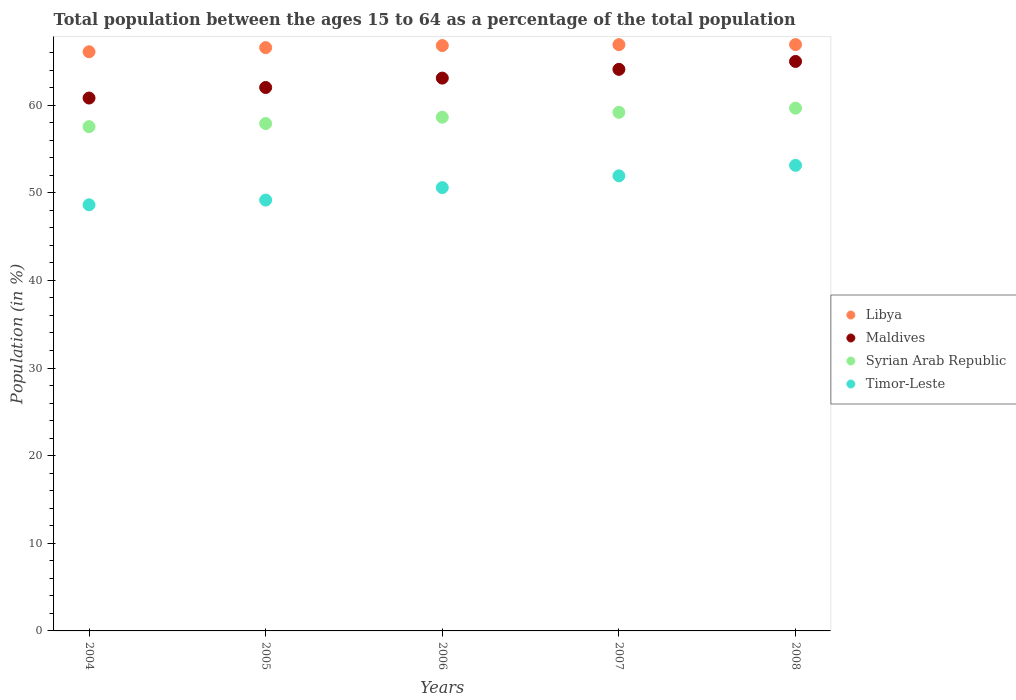How many different coloured dotlines are there?
Provide a succinct answer. 4. Is the number of dotlines equal to the number of legend labels?
Provide a short and direct response. Yes. What is the percentage of the population ages 15 to 64 in Maldives in 2006?
Your response must be concise. 63.08. Across all years, what is the maximum percentage of the population ages 15 to 64 in Syrian Arab Republic?
Ensure brevity in your answer.  59.65. Across all years, what is the minimum percentage of the population ages 15 to 64 in Maldives?
Offer a very short reply. 60.81. What is the total percentage of the population ages 15 to 64 in Timor-Leste in the graph?
Offer a terse response. 253.43. What is the difference between the percentage of the population ages 15 to 64 in Syrian Arab Republic in 2005 and that in 2006?
Make the answer very short. -0.72. What is the difference between the percentage of the population ages 15 to 64 in Maldives in 2006 and the percentage of the population ages 15 to 64 in Libya in 2007?
Keep it short and to the point. -3.82. What is the average percentage of the population ages 15 to 64 in Timor-Leste per year?
Ensure brevity in your answer.  50.69. In the year 2008, what is the difference between the percentage of the population ages 15 to 64 in Libya and percentage of the population ages 15 to 64 in Maldives?
Your answer should be compact. 1.92. In how many years, is the percentage of the population ages 15 to 64 in Timor-Leste greater than 24?
Keep it short and to the point. 5. What is the ratio of the percentage of the population ages 15 to 64 in Libya in 2005 to that in 2007?
Provide a succinct answer. 0.99. Is the percentage of the population ages 15 to 64 in Timor-Leste in 2005 less than that in 2008?
Your answer should be very brief. Yes. Is the difference between the percentage of the population ages 15 to 64 in Libya in 2005 and 2006 greater than the difference between the percentage of the population ages 15 to 64 in Maldives in 2005 and 2006?
Your response must be concise. Yes. What is the difference between the highest and the second highest percentage of the population ages 15 to 64 in Timor-Leste?
Give a very brief answer. 1.2. What is the difference between the highest and the lowest percentage of the population ages 15 to 64 in Syrian Arab Republic?
Offer a very short reply. 2.11. Is it the case that in every year, the sum of the percentage of the population ages 15 to 64 in Maldives and percentage of the population ages 15 to 64 in Timor-Leste  is greater than the sum of percentage of the population ages 15 to 64 in Syrian Arab Republic and percentage of the population ages 15 to 64 in Libya?
Your response must be concise. No. Is it the case that in every year, the sum of the percentage of the population ages 15 to 64 in Syrian Arab Republic and percentage of the population ages 15 to 64 in Maldives  is greater than the percentage of the population ages 15 to 64 in Libya?
Your answer should be very brief. Yes. Is the percentage of the population ages 15 to 64 in Syrian Arab Republic strictly greater than the percentage of the population ages 15 to 64 in Maldives over the years?
Ensure brevity in your answer.  No. Is the percentage of the population ages 15 to 64 in Syrian Arab Republic strictly less than the percentage of the population ages 15 to 64 in Maldives over the years?
Your answer should be very brief. Yes. How many years are there in the graph?
Your answer should be compact. 5. Are the values on the major ticks of Y-axis written in scientific E-notation?
Provide a succinct answer. No. Does the graph contain grids?
Your answer should be compact. No. Where does the legend appear in the graph?
Your answer should be very brief. Center right. What is the title of the graph?
Provide a succinct answer. Total population between the ages 15 to 64 as a percentage of the total population. What is the label or title of the Y-axis?
Make the answer very short. Population (in %). What is the Population (in %) of Libya in 2004?
Your answer should be compact. 66.09. What is the Population (in %) in Maldives in 2004?
Give a very brief answer. 60.81. What is the Population (in %) of Syrian Arab Republic in 2004?
Provide a succinct answer. 57.54. What is the Population (in %) of Timor-Leste in 2004?
Your response must be concise. 48.62. What is the Population (in %) of Libya in 2005?
Offer a terse response. 66.56. What is the Population (in %) of Maldives in 2005?
Make the answer very short. 62.01. What is the Population (in %) in Syrian Arab Republic in 2005?
Your answer should be compact. 57.9. What is the Population (in %) in Timor-Leste in 2005?
Give a very brief answer. 49.16. What is the Population (in %) of Libya in 2006?
Provide a succinct answer. 66.8. What is the Population (in %) in Maldives in 2006?
Offer a terse response. 63.08. What is the Population (in %) of Syrian Arab Republic in 2006?
Make the answer very short. 58.62. What is the Population (in %) in Timor-Leste in 2006?
Make the answer very short. 50.59. What is the Population (in %) of Libya in 2007?
Keep it short and to the point. 66.9. What is the Population (in %) of Maldives in 2007?
Ensure brevity in your answer.  64.08. What is the Population (in %) in Syrian Arab Republic in 2007?
Offer a terse response. 59.18. What is the Population (in %) of Timor-Leste in 2007?
Give a very brief answer. 51.93. What is the Population (in %) in Libya in 2008?
Your response must be concise. 66.91. What is the Population (in %) in Maldives in 2008?
Offer a very short reply. 64.98. What is the Population (in %) of Syrian Arab Republic in 2008?
Your response must be concise. 59.65. What is the Population (in %) of Timor-Leste in 2008?
Your answer should be compact. 53.13. Across all years, what is the maximum Population (in %) in Libya?
Keep it short and to the point. 66.91. Across all years, what is the maximum Population (in %) of Maldives?
Your response must be concise. 64.98. Across all years, what is the maximum Population (in %) of Syrian Arab Republic?
Your answer should be compact. 59.65. Across all years, what is the maximum Population (in %) of Timor-Leste?
Offer a terse response. 53.13. Across all years, what is the minimum Population (in %) in Libya?
Provide a succinct answer. 66.09. Across all years, what is the minimum Population (in %) in Maldives?
Offer a terse response. 60.81. Across all years, what is the minimum Population (in %) in Syrian Arab Republic?
Provide a short and direct response. 57.54. Across all years, what is the minimum Population (in %) in Timor-Leste?
Your answer should be compact. 48.62. What is the total Population (in %) of Libya in the graph?
Provide a short and direct response. 333.25. What is the total Population (in %) in Maldives in the graph?
Keep it short and to the point. 314.96. What is the total Population (in %) in Syrian Arab Republic in the graph?
Ensure brevity in your answer.  292.89. What is the total Population (in %) of Timor-Leste in the graph?
Keep it short and to the point. 253.43. What is the difference between the Population (in %) of Libya in 2004 and that in 2005?
Ensure brevity in your answer.  -0.47. What is the difference between the Population (in %) of Maldives in 2004 and that in 2005?
Give a very brief answer. -1.2. What is the difference between the Population (in %) of Syrian Arab Republic in 2004 and that in 2005?
Provide a succinct answer. -0.36. What is the difference between the Population (in %) of Timor-Leste in 2004 and that in 2005?
Offer a very short reply. -0.54. What is the difference between the Population (in %) of Libya in 2004 and that in 2006?
Your answer should be compact. -0.71. What is the difference between the Population (in %) in Maldives in 2004 and that in 2006?
Provide a succinct answer. -2.27. What is the difference between the Population (in %) of Syrian Arab Republic in 2004 and that in 2006?
Your answer should be compact. -1.08. What is the difference between the Population (in %) in Timor-Leste in 2004 and that in 2006?
Provide a short and direct response. -1.96. What is the difference between the Population (in %) of Libya in 2004 and that in 2007?
Give a very brief answer. -0.81. What is the difference between the Population (in %) of Maldives in 2004 and that in 2007?
Make the answer very short. -3.27. What is the difference between the Population (in %) in Syrian Arab Republic in 2004 and that in 2007?
Make the answer very short. -1.63. What is the difference between the Population (in %) in Timor-Leste in 2004 and that in 2007?
Provide a succinct answer. -3.31. What is the difference between the Population (in %) in Libya in 2004 and that in 2008?
Keep it short and to the point. -0.82. What is the difference between the Population (in %) of Maldives in 2004 and that in 2008?
Give a very brief answer. -4.18. What is the difference between the Population (in %) of Syrian Arab Republic in 2004 and that in 2008?
Your answer should be compact. -2.11. What is the difference between the Population (in %) of Timor-Leste in 2004 and that in 2008?
Offer a terse response. -4.5. What is the difference between the Population (in %) in Libya in 2005 and that in 2006?
Offer a very short reply. -0.24. What is the difference between the Population (in %) in Maldives in 2005 and that in 2006?
Keep it short and to the point. -1.07. What is the difference between the Population (in %) of Syrian Arab Republic in 2005 and that in 2006?
Keep it short and to the point. -0.72. What is the difference between the Population (in %) of Timor-Leste in 2005 and that in 2006?
Offer a terse response. -1.42. What is the difference between the Population (in %) in Libya in 2005 and that in 2007?
Give a very brief answer. -0.34. What is the difference between the Population (in %) of Maldives in 2005 and that in 2007?
Give a very brief answer. -2.07. What is the difference between the Population (in %) in Syrian Arab Republic in 2005 and that in 2007?
Your response must be concise. -1.28. What is the difference between the Population (in %) of Timor-Leste in 2005 and that in 2007?
Provide a succinct answer. -2.77. What is the difference between the Population (in %) in Libya in 2005 and that in 2008?
Make the answer very short. -0.35. What is the difference between the Population (in %) of Maldives in 2005 and that in 2008?
Your response must be concise. -2.97. What is the difference between the Population (in %) in Syrian Arab Republic in 2005 and that in 2008?
Keep it short and to the point. -1.75. What is the difference between the Population (in %) of Timor-Leste in 2005 and that in 2008?
Your response must be concise. -3.96. What is the difference between the Population (in %) of Libya in 2006 and that in 2007?
Offer a terse response. -0.1. What is the difference between the Population (in %) of Maldives in 2006 and that in 2007?
Ensure brevity in your answer.  -1. What is the difference between the Population (in %) in Syrian Arab Republic in 2006 and that in 2007?
Your answer should be very brief. -0.56. What is the difference between the Population (in %) of Timor-Leste in 2006 and that in 2007?
Give a very brief answer. -1.34. What is the difference between the Population (in %) of Libya in 2006 and that in 2008?
Offer a terse response. -0.11. What is the difference between the Population (in %) of Maldives in 2006 and that in 2008?
Ensure brevity in your answer.  -1.9. What is the difference between the Population (in %) in Syrian Arab Republic in 2006 and that in 2008?
Offer a terse response. -1.03. What is the difference between the Population (in %) of Timor-Leste in 2006 and that in 2008?
Make the answer very short. -2.54. What is the difference between the Population (in %) of Libya in 2007 and that in 2008?
Provide a succinct answer. -0.01. What is the difference between the Population (in %) of Maldives in 2007 and that in 2008?
Make the answer very short. -0.9. What is the difference between the Population (in %) of Syrian Arab Republic in 2007 and that in 2008?
Offer a terse response. -0.47. What is the difference between the Population (in %) in Timor-Leste in 2007 and that in 2008?
Give a very brief answer. -1.2. What is the difference between the Population (in %) in Libya in 2004 and the Population (in %) in Maldives in 2005?
Give a very brief answer. 4.08. What is the difference between the Population (in %) in Libya in 2004 and the Population (in %) in Syrian Arab Republic in 2005?
Provide a short and direct response. 8.19. What is the difference between the Population (in %) in Libya in 2004 and the Population (in %) in Timor-Leste in 2005?
Offer a very short reply. 16.92. What is the difference between the Population (in %) of Maldives in 2004 and the Population (in %) of Syrian Arab Republic in 2005?
Provide a short and direct response. 2.91. What is the difference between the Population (in %) in Maldives in 2004 and the Population (in %) in Timor-Leste in 2005?
Your response must be concise. 11.64. What is the difference between the Population (in %) in Syrian Arab Republic in 2004 and the Population (in %) in Timor-Leste in 2005?
Provide a succinct answer. 8.38. What is the difference between the Population (in %) in Libya in 2004 and the Population (in %) in Maldives in 2006?
Keep it short and to the point. 3.01. What is the difference between the Population (in %) in Libya in 2004 and the Population (in %) in Syrian Arab Republic in 2006?
Your answer should be very brief. 7.47. What is the difference between the Population (in %) of Libya in 2004 and the Population (in %) of Timor-Leste in 2006?
Your response must be concise. 15.5. What is the difference between the Population (in %) of Maldives in 2004 and the Population (in %) of Syrian Arab Republic in 2006?
Your answer should be very brief. 2.19. What is the difference between the Population (in %) of Maldives in 2004 and the Population (in %) of Timor-Leste in 2006?
Offer a terse response. 10.22. What is the difference between the Population (in %) in Syrian Arab Republic in 2004 and the Population (in %) in Timor-Leste in 2006?
Keep it short and to the point. 6.96. What is the difference between the Population (in %) in Libya in 2004 and the Population (in %) in Maldives in 2007?
Your response must be concise. 2.01. What is the difference between the Population (in %) in Libya in 2004 and the Population (in %) in Syrian Arab Republic in 2007?
Your answer should be very brief. 6.91. What is the difference between the Population (in %) of Libya in 2004 and the Population (in %) of Timor-Leste in 2007?
Provide a short and direct response. 14.16. What is the difference between the Population (in %) of Maldives in 2004 and the Population (in %) of Syrian Arab Republic in 2007?
Your response must be concise. 1.63. What is the difference between the Population (in %) of Maldives in 2004 and the Population (in %) of Timor-Leste in 2007?
Provide a succinct answer. 8.88. What is the difference between the Population (in %) of Syrian Arab Republic in 2004 and the Population (in %) of Timor-Leste in 2007?
Give a very brief answer. 5.61. What is the difference between the Population (in %) in Libya in 2004 and the Population (in %) in Maldives in 2008?
Give a very brief answer. 1.11. What is the difference between the Population (in %) of Libya in 2004 and the Population (in %) of Syrian Arab Republic in 2008?
Keep it short and to the point. 6.44. What is the difference between the Population (in %) of Libya in 2004 and the Population (in %) of Timor-Leste in 2008?
Your response must be concise. 12.96. What is the difference between the Population (in %) of Maldives in 2004 and the Population (in %) of Syrian Arab Republic in 2008?
Provide a short and direct response. 1.16. What is the difference between the Population (in %) in Maldives in 2004 and the Population (in %) in Timor-Leste in 2008?
Provide a short and direct response. 7.68. What is the difference between the Population (in %) of Syrian Arab Republic in 2004 and the Population (in %) of Timor-Leste in 2008?
Make the answer very short. 4.42. What is the difference between the Population (in %) of Libya in 2005 and the Population (in %) of Maldives in 2006?
Keep it short and to the point. 3.48. What is the difference between the Population (in %) of Libya in 2005 and the Population (in %) of Syrian Arab Republic in 2006?
Make the answer very short. 7.94. What is the difference between the Population (in %) of Libya in 2005 and the Population (in %) of Timor-Leste in 2006?
Your answer should be very brief. 15.97. What is the difference between the Population (in %) in Maldives in 2005 and the Population (in %) in Syrian Arab Republic in 2006?
Make the answer very short. 3.39. What is the difference between the Population (in %) of Maldives in 2005 and the Population (in %) of Timor-Leste in 2006?
Give a very brief answer. 11.42. What is the difference between the Population (in %) in Syrian Arab Republic in 2005 and the Population (in %) in Timor-Leste in 2006?
Your answer should be compact. 7.31. What is the difference between the Population (in %) of Libya in 2005 and the Population (in %) of Maldives in 2007?
Offer a terse response. 2.48. What is the difference between the Population (in %) in Libya in 2005 and the Population (in %) in Syrian Arab Republic in 2007?
Offer a terse response. 7.38. What is the difference between the Population (in %) of Libya in 2005 and the Population (in %) of Timor-Leste in 2007?
Your answer should be compact. 14.63. What is the difference between the Population (in %) in Maldives in 2005 and the Population (in %) in Syrian Arab Republic in 2007?
Offer a terse response. 2.83. What is the difference between the Population (in %) in Maldives in 2005 and the Population (in %) in Timor-Leste in 2007?
Your answer should be compact. 10.08. What is the difference between the Population (in %) in Syrian Arab Republic in 2005 and the Population (in %) in Timor-Leste in 2007?
Your response must be concise. 5.97. What is the difference between the Population (in %) in Libya in 2005 and the Population (in %) in Maldives in 2008?
Make the answer very short. 1.58. What is the difference between the Population (in %) of Libya in 2005 and the Population (in %) of Syrian Arab Republic in 2008?
Your answer should be very brief. 6.91. What is the difference between the Population (in %) in Libya in 2005 and the Population (in %) in Timor-Leste in 2008?
Offer a terse response. 13.43. What is the difference between the Population (in %) in Maldives in 2005 and the Population (in %) in Syrian Arab Republic in 2008?
Your answer should be very brief. 2.36. What is the difference between the Population (in %) of Maldives in 2005 and the Population (in %) of Timor-Leste in 2008?
Provide a succinct answer. 8.88. What is the difference between the Population (in %) in Syrian Arab Republic in 2005 and the Population (in %) in Timor-Leste in 2008?
Provide a succinct answer. 4.77. What is the difference between the Population (in %) in Libya in 2006 and the Population (in %) in Maldives in 2007?
Ensure brevity in your answer.  2.72. What is the difference between the Population (in %) in Libya in 2006 and the Population (in %) in Syrian Arab Republic in 2007?
Provide a succinct answer. 7.62. What is the difference between the Population (in %) in Libya in 2006 and the Population (in %) in Timor-Leste in 2007?
Offer a terse response. 14.87. What is the difference between the Population (in %) of Maldives in 2006 and the Population (in %) of Syrian Arab Republic in 2007?
Give a very brief answer. 3.9. What is the difference between the Population (in %) in Maldives in 2006 and the Population (in %) in Timor-Leste in 2007?
Give a very brief answer. 11.15. What is the difference between the Population (in %) of Syrian Arab Republic in 2006 and the Population (in %) of Timor-Leste in 2007?
Ensure brevity in your answer.  6.69. What is the difference between the Population (in %) of Libya in 2006 and the Population (in %) of Maldives in 2008?
Keep it short and to the point. 1.81. What is the difference between the Population (in %) of Libya in 2006 and the Population (in %) of Syrian Arab Republic in 2008?
Your answer should be compact. 7.15. What is the difference between the Population (in %) in Libya in 2006 and the Population (in %) in Timor-Leste in 2008?
Provide a succinct answer. 13.67. What is the difference between the Population (in %) in Maldives in 2006 and the Population (in %) in Syrian Arab Republic in 2008?
Ensure brevity in your answer.  3.43. What is the difference between the Population (in %) in Maldives in 2006 and the Population (in %) in Timor-Leste in 2008?
Your answer should be compact. 9.96. What is the difference between the Population (in %) of Syrian Arab Republic in 2006 and the Population (in %) of Timor-Leste in 2008?
Your response must be concise. 5.49. What is the difference between the Population (in %) in Libya in 2007 and the Population (in %) in Maldives in 2008?
Offer a very short reply. 1.92. What is the difference between the Population (in %) in Libya in 2007 and the Population (in %) in Syrian Arab Republic in 2008?
Your answer should be very brief. 7.25. What is the difference between the Population (in %) of Libya in 2007 and the Population (in %) of Timor-Leste in 2008?
Your answer should be compact. 13.77. What is the difference between the Population (in %) in Maldives in 2007 and the Population (in %) in Syrian Arab Republic in 2008?
Offer a terse response. 4.43. What is the difference between the Population (in %) in Maldives in 2007 and the Population (in %) in Timor-Leste in 2008?
Your response must be concise. 10.95. What is the difference between the Population (in %) in Syrian Arab Republic in 2007 and the Population (in %) in Timor-Leste in 2008?
Offer a very short reply. 6.05. What is the average Population (in %) in Libya per year?
Your response must be concise. 66.65. What is the average Population (in %) in Maldives per year?
Offer a very short reply. 62.99. What is the average Population (in %) of Syrian Arab Republic per year?
Give a very brief answer. 58.58. What is the average Population (in %) in Timor-Leste per year?
Offer a terse response. 50.69. In the year 2004, what is the difference between the Population (in %) in Libya and Population (in %) in Maldives?
Your answer should be compact. 5.28. In the year 2004, what is the difference between the Population (in %) of Libya and Population (in %) of Syrian Arab Republic?
Provide a succinct answer. 8.54. In the year 2004, what is the difference between the Population (in %) in Libya and Population (in %) in Timor-Leste?
Keep it short and to the point. 17.46. In the year 2004, what is the difference between the Population (in %) of Maldives and Population (in %) of Syrian Arab Republic?
Provide a short and direct response. 3.26. In the year 2004, what is the difference between the Population (in %) in Maldives and Population (in %) in Timor-Leste?
Your answer should be compact. 12.18. In the year 2004, what is the difference between the Population (in %) in Syrian Arab Republic and Population (in %) in Timor-Leste?
Your response must be concise. 8.92. In the year 2005, what is the difference between the Population (in %) in Libya and Population (in %) in Maldives?
Your answer should be compact. 4.55. In the year 2005, what is the difference between the Population (in %) in Libya and Population (in %) in Syrian Arab Republic?
Offer a terse response. 8.66. In the year 2005, what is the difference between the Population (in %) in Libya and Population (in %) in Timor-Leste?
Your answer should be very brief. 17.39. In the year 2005, what is the difference between the Population (in %) in Maldives and Population (in %) in Syrian Arab Republic?
Ensure brevity in your answer.  4.11. In the year 2005, what is the difference between the Population (in %) of Maldives and Population (in %) of Timor-Leste?
Offer a terse response. 12.85. In the year 2005, what is the difference between the Population (in %) in Syrian Arab Republic and Population (in %) in Timor-Leste?
Offer a very short reply. 8.73. In the year 2006, what is the difference between the Population (in %) in Libya and Population (in %) in Maldives?
Ensure brevity in your answer.  3.71. In the year 2006, what is the difference between the Population (in %) of Libya and Population (in %) of Syrian Arab Republic?
Your answer should be very brief. 8.18. In the year 2006, what is the difference between the Population (in %) in Libya and Population (in %) in Timor-Leste?
Keep it short and to the point. 16.21. In the year 2006, what is the difference between the Population (in %) in Maldives and Population (in %) in Syrian Arab Republic?
Your answer should be compact. 4.46. In the year 2006, what is the difference between the Population (in %) in Maldives and Population (in %) in Timor-Leste?
Ensure brevity in your answer.  12.49. In the year 2006, what is the difference between the Population (in %) of Syrian Arab Republic and Population (in %) of Timor-Leste?
Your answer should be very brief. 8.03. In the year 2007, what is the difference between the Population (in %) in Libya and Population (in %) in Maldives?
Give a very brief answer. 2.82. In the year 2007, what is the difference between the Population (in %) in Libya and Population (in %) in Syrian Arab Republic?
Give a very brief answer. 7.72. In the year 2007, what is the difference between the Population (in %) in Libya and Population (in %) in Timor-Leste?
Offer a very short reply. 14.97. In the year 2007, what is the difference between the Population (in %) in Maldives and Population (in %) in Syrian Arab Republic?
Your answer should be compact. 4.9. In the year 2007, what is the difference between the Population (in %) in Maldives and Population (in %) in Timor-Leste?
Ensure brevity in your answer.  12.15. In the year 2007, what is the difference between the Population (in %) in Syrian Arab Republic and Population (in %) in Timor-Leste?
Your answer should be compact. 7.25. In the year 2008, what is the difference between the Population (in %) in Libya and Population (in %) in Maldives?
Offer a very short reply. 1.92. In the year 2008, what is the difference between the Population (in %) of Libya and Population (in %) of Syrian Arab Republic?
Your answer should be very brief. 7.26. In the year 2008, what is the difference between the Population (in %) in Libya and Population (in %) in Timor-Leste?
Offer a very short reply. 13.78. In the year 2008, what is the difference between the Population (in %) in Maldives and Population (in %) in Syrian Arab Republic?
Provide a succinct answer. 5.33. In the year 2008, what is the difference between the Population (in %) in Maldives and Population (in %) in Timor-Leste?
Offer a terse response. 11.86. In the year 2008, what is the difference between the Population (in %) in Syrian Arab Republic and Population (in %) in Timor-Leste?
Offer a very short reply. 6.53. What is the ratio of the Population (in %) in Maldives in 2004 to that in 2005?
Your answer should be very brief. 0.98. What is the ratio of the Population (in %) in Libya in 2004 to that in 2006?
Offer a terse response. 0.99. What is the ratio of the Population (in %) in Maldives in 2004 to that in 2006?
Keep it short and to the point. 0.96. What is the ratio of the Population (in %) in Syrian Arab Republic in 2004 to that in 2006?
Keep it short and to the point. 0.98. What is the ratio of the Population (in %) in Timor-Leste in 2004 to that in 2006?
Provide a short and direct response. 0.96. What is the ratio of the Population (in %) in Libya in 2004 to that in 2007?
Your answer should be very brief. 0.99. What is the ratio of the Population (in %) in Maldives in 2004 to that in 2007?
Offer a terse response. 0.95. What is the ratio of the Population (in %) in Syrian Arab Republic in 2004 to that in 2007?
Your response must be concise. 0.97. What is the ratio of the Population (in %) in Timor-Leste in 2004 to that in 2007?
Provide a short and direct response. 0.94. What is the ratio of the Population (in %) of Maldives in 2004 to that in 2008?
Offer a very short reply. 0.94. What is the ratio of the Population (in %) of Syrian Arab Republic in 2004 to that in 2008?
Offer a terse response. 0.96. What is the ratio of the Population (in %) of Timor-Leste in 2004 to that in 2008?
Give a very brief answer. 0.92. What is the ratio of the Population (in %) of Maldives in 2005 to that in 2006?
Provide a succinct answer. 0.98. What is the ratio of the Population (in %) of Syrian Arab Republic in 2005 to that in 2006?
Provide a succinct answer. 0.99. What is the ratio of the Population (in %) in Timor-Leste in 2005 to that in 2006?
Make the answer very short. 0.97. What is the ratio of the Population (in %) in Maldives in 2005 to that in 2007?
Keep it short and to the point. 0.97. What is the ratio of the Population (in %) of Syrian Arab Republic in 2005 to that in 2007?
Your answer should be very brief. 0.98. What is the ratio of the Population (in %) of Timor-Leste in 2005 to that in 2007?
Provide a short and direct response. 0.95. What is the ratio of the Population (in %) in Libya in 2005 to that in 2008?
Keep it short and to the point. 0.99. What is the ratio of the Population (in %) of Maldives in 2005 to that in 2008?
Provide a succinct answer. 0.95. What is the ratio of the Population (in %) of Syrian Arab Republic in 2005 to that in 2008?
Make the answer very short. 0.97. What is the ratio of the Population (in %) in Timor-Leste in 2005 to that in 2008?
Provide a succinct answer. 0.93. What is the ratio of the Population (in %) of Maldives in 2006 to that in 2007?
Keep it short and to the point. 0.98. What is the ratio of the Population (in %) of Syrian Arab Republic in 2006 to that in 2007?
Your response must be concise. 0.99. What is the ratio of the Population (in %) in Timor-Leste in 2006 to that in 2007?
Your answer should be compact. 0.97. What is the ratio of the Population (in %) in Libya in 2006 to that in 2008?
Ensure brevity in your answer.  1. What is the ratio of the Population (in %) of Maldives in 2006 to that in 2008?
Provide a short and direct response. 0.97. What is the ratio of the Population (in %) in Syrian Arab Republic in 2006 to that in 2008?
Keep it short and to the point. 0.98. What is the ratio of the Population (in %) of Timor-Leste in 2006 to that in 2008?
Offer a terse response. 0.95. What is the ratio of the Population (in %) in Libya in 2007 to that in 2008?
Your answer should be very brief. 1. What is the ratio of the Population (in %) in Maldives in 2007 to that in 2008?
Provide a succinct answer. 0.99. What is the ratio of the Population (in %) of Syrian Arab Republic in 2007 to that in 2008?
Give a very brief answer. 0.99. What is the ratio of the Population (in %) of Timor-Leste in 2007 to that in 2008?
Offer a very short reply. 0.98. What is the difference between the highest and the second highest Population (in %) of Libya?
Your answer should be very brief. 0.01. What is the difference between the highest and the second highest Population (in %) in Maldives?
Your response must be concise. 0.9. What is the difference between the highest and the second highest Population (in %) of Syrian Arab Republic?
Your answer should be compact. 0.47. What is the difference between the highest and the second highest Population (in %) in Timor-Leste?
Offer a terse response. 1.2. What is the difference between the highest and the lowest Population (in %) of Libya?
Your answer should be very brief. 0.82. What is the difference between the highest and the lowest Population (in %) in Maldives?
Provide a short and direct response. 4.18. What is the difference between the highest and the lowest Population (in %) in Syrian Arab Republic?
Ensure brevity in your answer.  2.11. What is the difference between the highest and the lowest Population (in %) of Timor-Leste?
Your answer should be very brief. 4.5. 